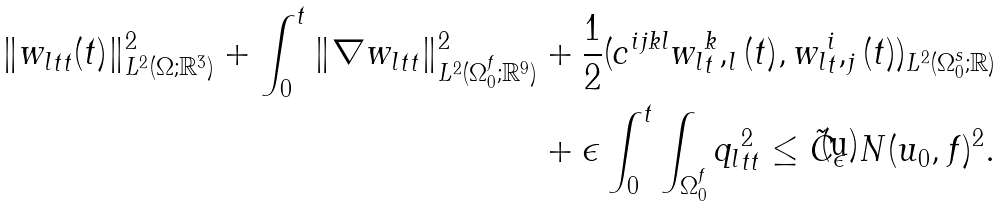Convert formula to latex. <formula><loc_0><loc_0><loc_500><loc_500>\| { w _ { l } } _ { t t } ( t ) \| ^ { 2 } _ { L ^ { 2 } ( \Omega ; { \mathbb { R } } ^ { 3 } ) } + \int _ { 0 } ^ { t } \| \nabla { w _ { l } } _ { t t } \| ^ { 2 } _ { L ^ { 2 } ( \Omega _ { 0 } ^ { f } ; { \mathbb { R } } ^ { 9 } ) } & + \frac { 1 } { 2 } ( c ^ { i j k l } { w _ { l } } _ { t } ^ { k } , _ { l } ( t ) , { w _ { l } } _ { t } ^ { i } , _ { j } ( t ) ) _ { L ^ { 2 } ( \Omega _ { 0 } ^ { s } ; { \mathbb { R } } ) } \\ & + \epsilon \int _ { 0 } ^ { t } \int _ { \Omega _ { 0 } ^ { f } } { q _ { l } } ^ { 2 } _ { t t } \leq \tilde { C } _ { \epsilon } \ N ( u _ { 0 } , f ) ^ { 2 } .</formula> 